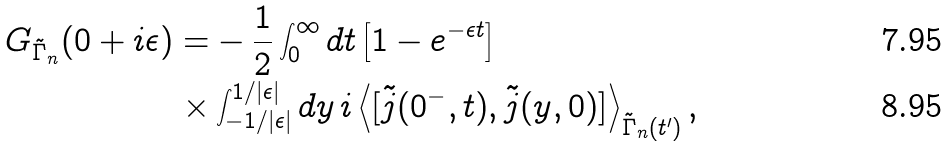Convert formula to latex. <formula><loc_0><loc_0><loc_500><loc_500>G _ { \tilde { \Gamma } _ { n } } ( 0 + i \epsilon ) = & - \frac { 1 } { 2 } \int _ { 0 } ^ { \infty } d t \left [ 1 - e ^ { - \epsilon t } \right ] \\ \times & \int _ { - 1 / | \epsilon | } ^ { 1 / | \epsilon | } d y \, i \left \langle [ \tilde { j } ( 0 ^ { - } , t ) , \tilde { j } ( y , 0 ) ] \right \rangle _ { \tilde { \Gamma } _ { n } ( t ^ { \prime } ) } ,</formula> 